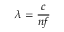Convert formula to latex. <formula><loc_0><loc_0><loc_500><loc_500>\lambda = { \frac { c } { n f } }</formula> 